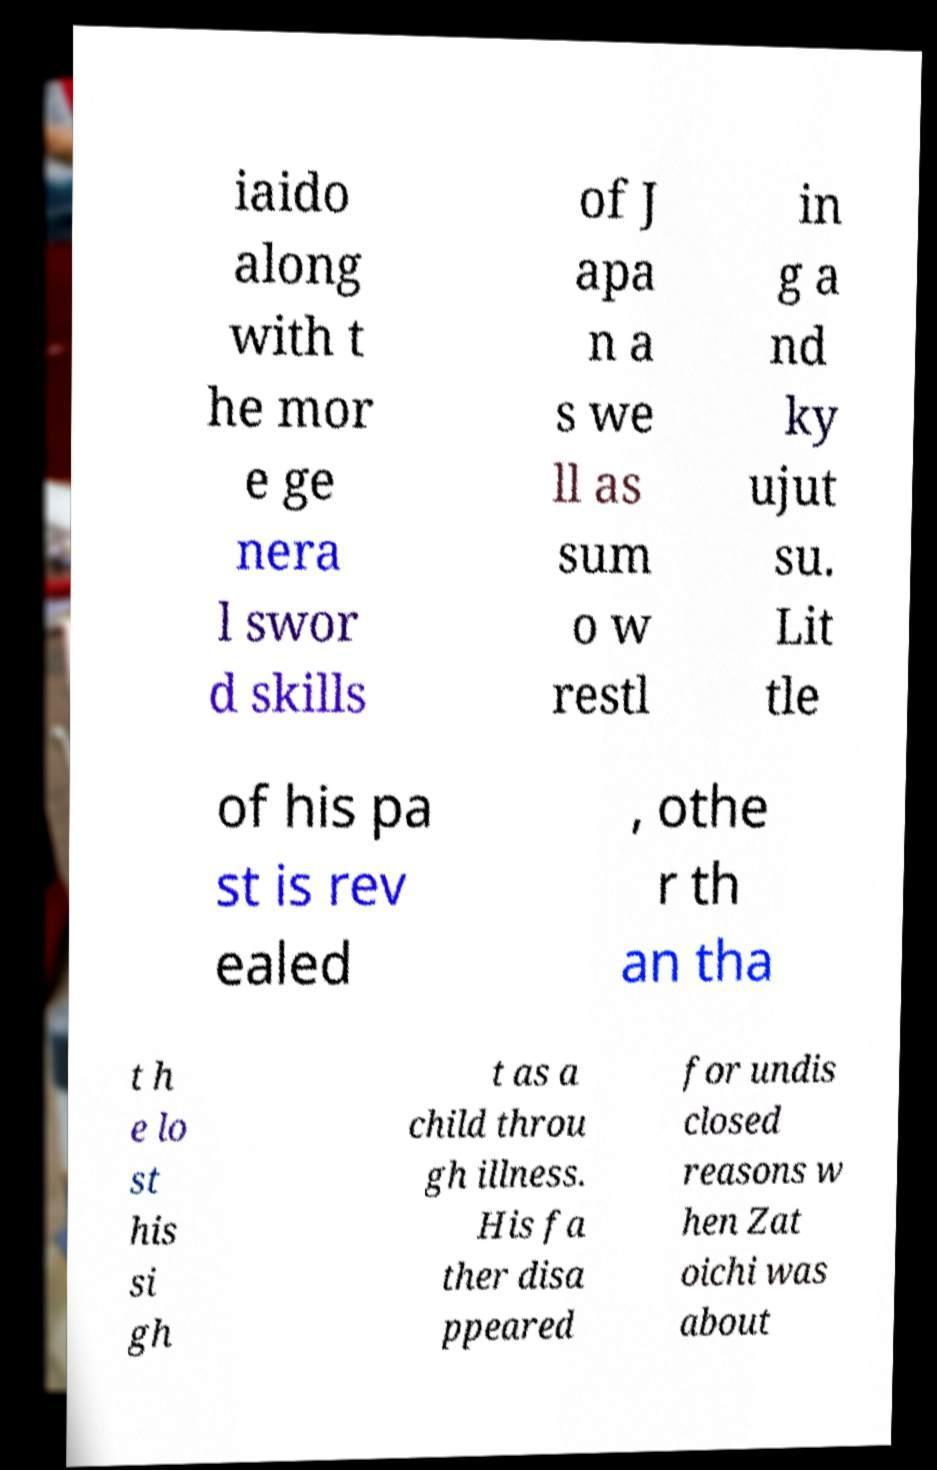Could you extract and type out the text from this image? iaido along with t he mor e ge nera l swor d skills of J apa n a s we ll as sum o w restl in g a nd ky ujut su. Lit tle of his pa st is rev ealed , othe r th an tha t h e lo st his si gh t as a child throu gh illness. His fa ther disa ppeared for undis closed reasons w hen Zat oichi was about 